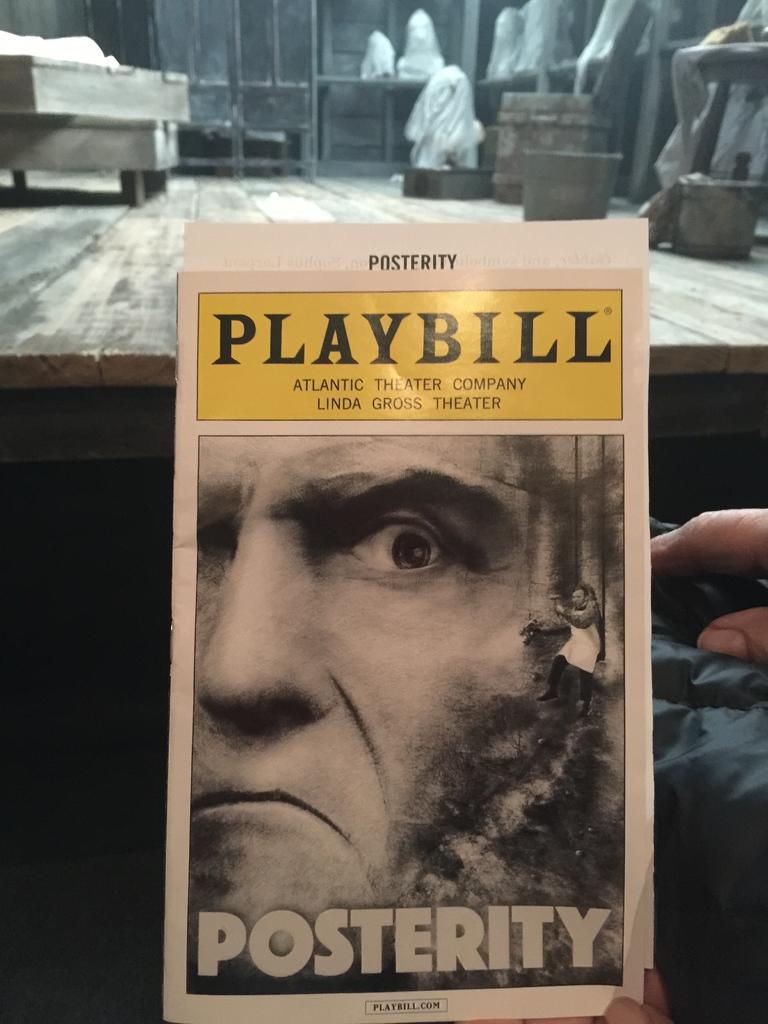What does the word on his face say?
Your response must be concise. Posterity. Whats the title of the book?
Ensure brevity in your answer.  Posterity. 